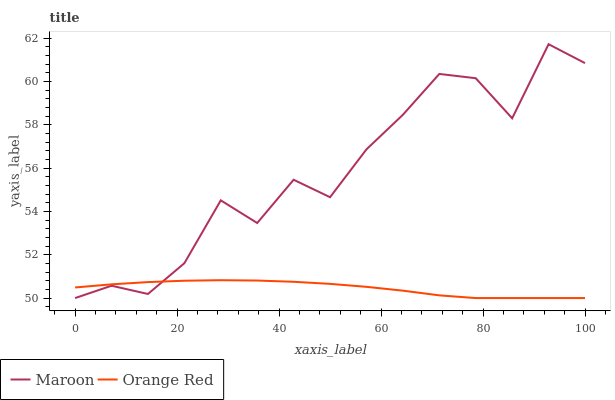Does Orange Red have the minimum area under the curve?
Answer yes or no. Yes. Does Maroon have the maximum area under the curve?
Answer yes or no. Yes. Does Maroon have the minimum area under the curve?
Answer yes or no. No. Is Orange Red the smoothest?
Answer yes or no. Yes. Is Maroon the roughest?
Answer yes or no. Yes. Is Maroon the smoothest?
Answer yes or no. No. Does Maroon have the highest value?
Answer yes or no. Yes. 